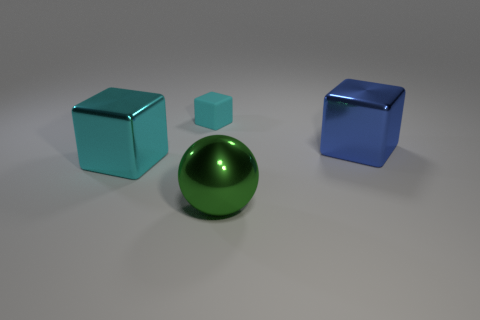Subtract all green blocks. Subtract all brown balls. How many blocks are left? 3 Add 3 large spheres. How many objects exist? 7 Subtract all spheres. How many objects are left? 3 Add 4 shiny things. How many shiny things are left? 7 Add 4 matte things. How many matte things exist? 5 Subtract 0 gray blocks. How many objects are left? 4 Subtract all green rubber cylinders. Subtract all large shiny blocks. How many objects are left? 2 